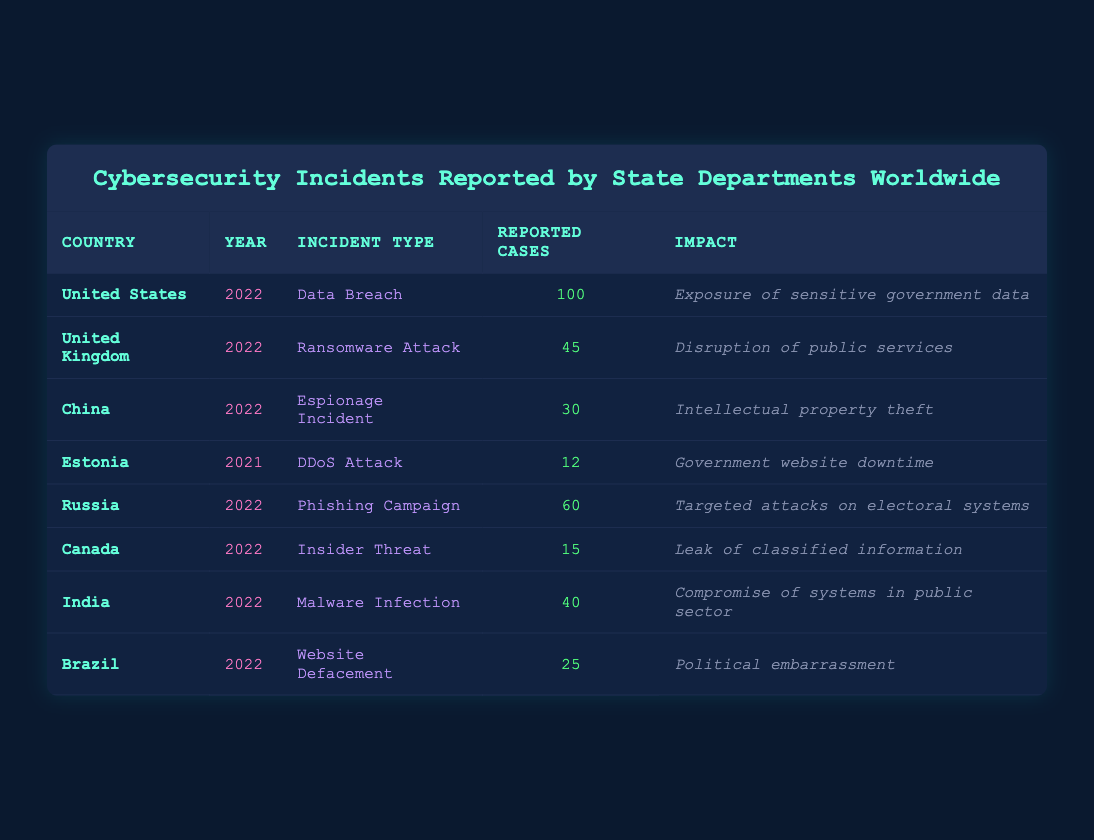What is the incident type reported by Canada in 2022? The table lists the incidents for Canada in the year 2022, which shows that the incident type is an Insider Threat.
Answer: Insider Threat How many reported cases were there for ransomware attacks in the United Kingdom in 2022? Referring to the row for the United Kingdom, the table indicates that there were 45 reported cases of ransomware attacks in 2022.
Answer: 45 Which country reported the highest number of cybersecurity incidents in 2022? The data shows that the United States reported the highest number of cases with 100 reported cases, compared to other countries in 2022.
Answer: United States What was the total number of reported cases for phishing campaigns and malware infections combined in 2022? Summing the reported cases: Phishing Campaign (60) + Malware Infection (40) gives a total of 100 reported cases.
Answer: 100 Is it true that China reported more incidents of espionage than India reported malware infections in 2022? The table reveals China reported 30 incidents of espionage and India reported 40 malware infections; therefore, the statement is false.
Answer: No What is the impact of the DDoS attack reported by Estonia in 2021? Looking at the table, the impact listed for the DDoS attack in Estonia is government website downtime.
Answer: Government website downtime In which year did Brazil report a website defacement incident, and how many cases were reported? Brazil reported a website defacement incident in 2022 with a total of 25 cases.
Answer: 2022, 25 What would be the average number of reported cases for the incidents listed in the table? The total number of reported cases for all incidents in the table is 412 (100 + 45 + 30 + 12 + 60 + 15 + 40 + 25 = 412) and there are 8 incidents; hence, the average is 412/8 = 51.5.
Answer: 51.5 Which two countries reported more than 40 cases in 2022, and what were the incident types? The two countries are the United States (Data Breach, 100 cases) and Russia (Phishing Campaign, 60 cases) reported more than 40 cases in 2022.
Answer: United States (Data Breach), Russia (Phishing Campaign) 